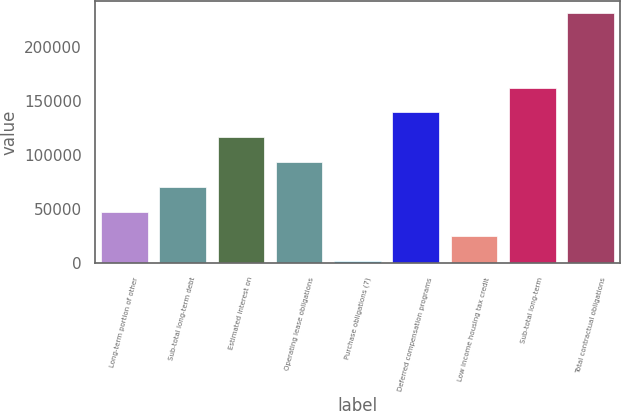<chart> <loc_0><loc_0><loc_500><loc_500><bar_chart><fcel>Long-term portion of other<fcel>Sub-total long-term debt<fcel>Estimated interest on<fcel>Operating lease obligations<fcel>Purchase obligations (7)<fcel>Deferred compensation programs<fcel>Low income housing tax credit<fcel>Sub-total long-term<fcel>Total contractual obligations<nl><fcel>47861.8<fcel>70776.2<fcel>116605<fcel>93690.6<fcel>2033<fcel>139519<fcel>24947.4<fcel>162434<fcel>231177<nl></chart> 